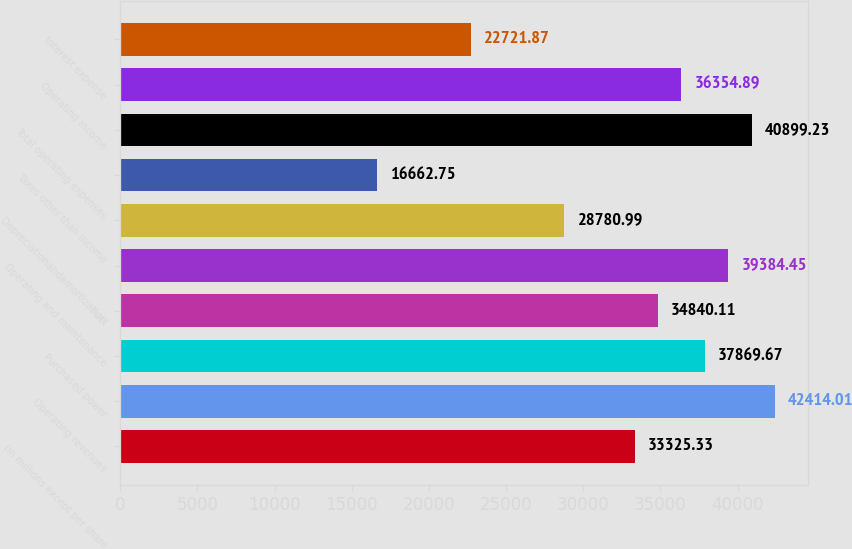Convert chart to OTSL. <chart><loc_0><loc_0><loc_500><loc_500><bar_chart><fcel>(in millions except per share<fcel>Operating revenues<fcel>Purchased power<fcel>Fuel<fcel>Operating and maintenance<fcel>Depreciationandamortization<fcel>Taxes other than income<fcel>Total operating expenses<fcel>Operating income<fcel>Interest expense<nl><fcel>33325.3<fcel>42414<fcel>37869.7<fcel>34840.1<fcel>39384.4<fcel>28781<fcel>16662.8<fcel>40899.2<fcel>36354.9<fcel>22721.9<nl></chart> 